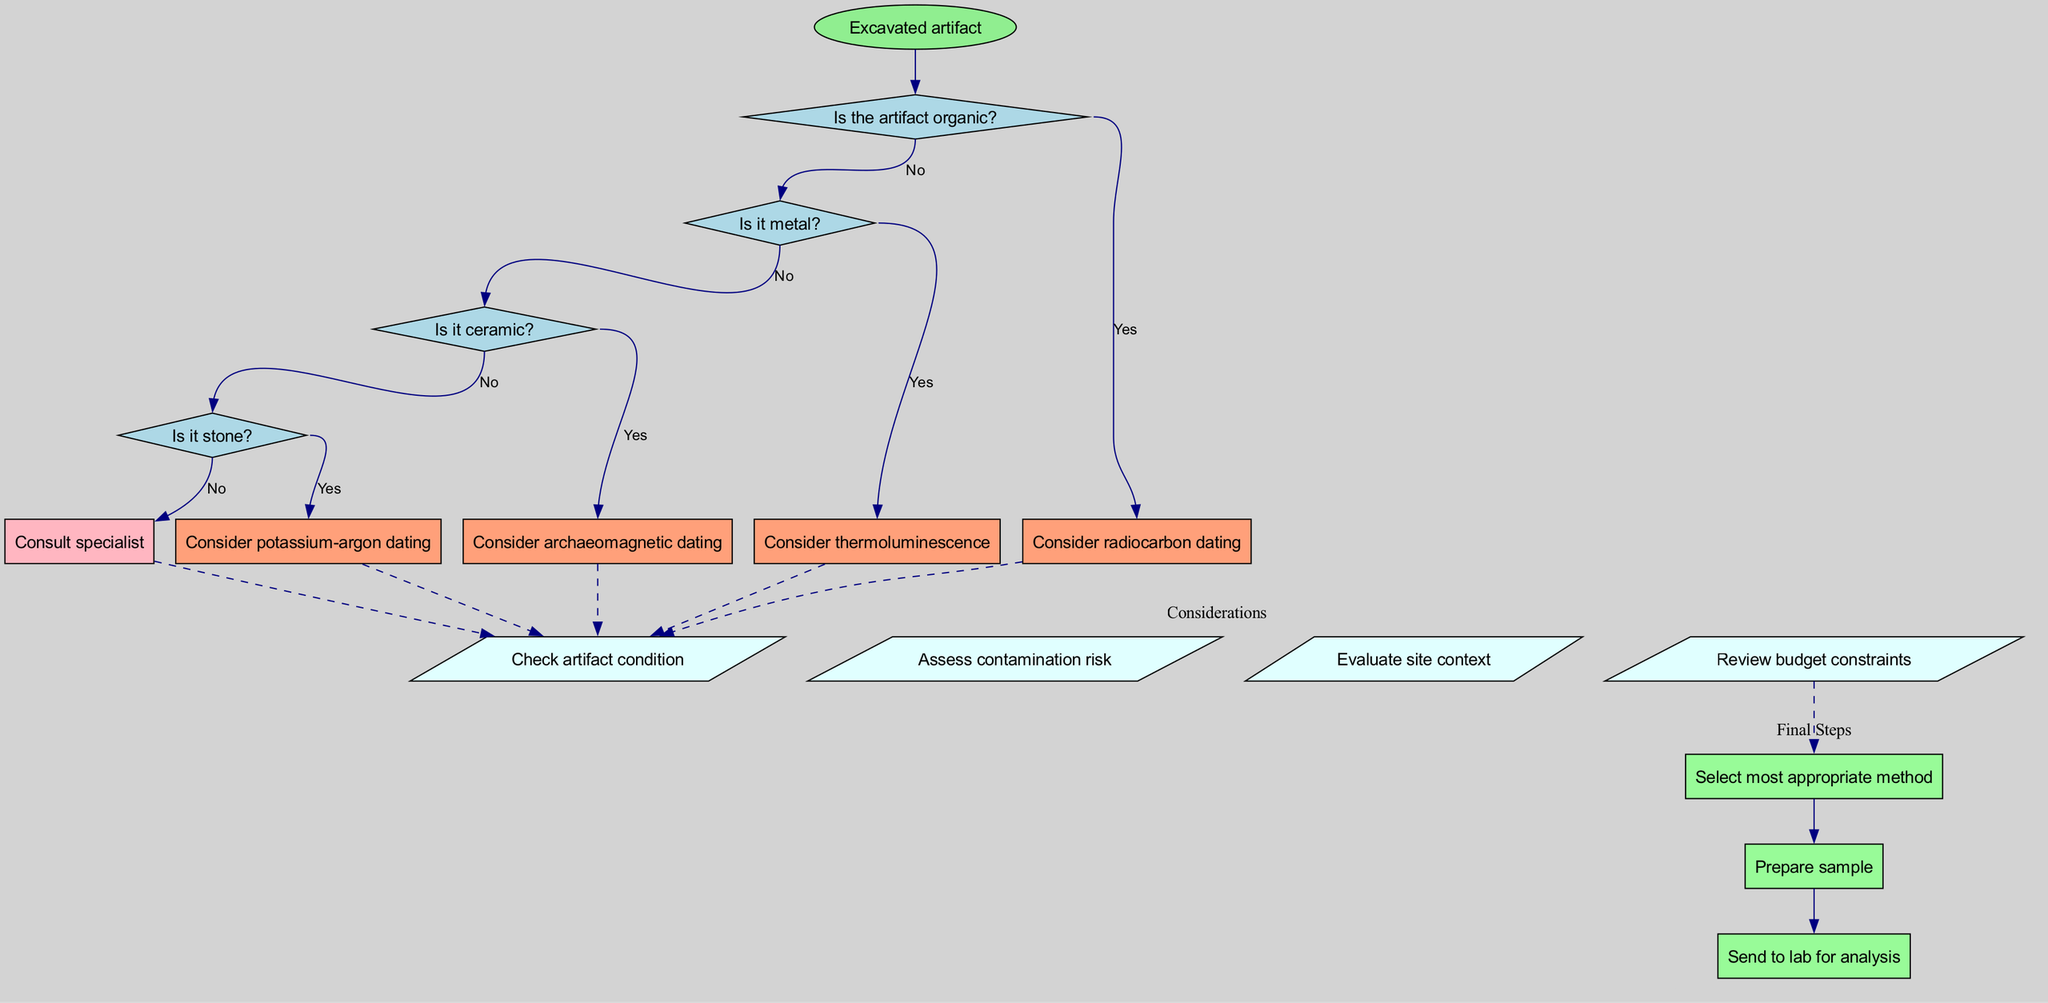What is the starting point of the flow chart? The starting point of the flow chart is represented by the "Excavated artifact" node, which is the initial consideration for the decision-making process regarding artifact dating.
Answer: Excavated artifact How many decisions are represented in the diagram? The diagram contains four decision nodes related to determining the appropriate dating method based on the artifact's type and condition, indicating a branching process for decision-making.
Answer: 4 What dating method should be considered for organic artifacts? If an artifact is determined to be organic, the decision leads to considering radiocarbon dating as the appropriate method for dating such materials.
Answer: Radiocarbon dating What should be consulted if the artifact is stone? If the artifact is identified as stone, and the answer to the prior questions is no, the final action is to "Consult specialist" for guidance on applicable dating methods.
Answer: Consult specialist Which method is suggested for ceramic artifacts? When identifying ceramic artifacts, the flow chart indicates that archaeomagnetic dating should be considered as the appropriate dating method for such materials.
Answer: Archaeomagnetic dating What is the connection between considerations and final steps? The considerations serve as important factors to evaluate before proceeding to the final steps, emphasizing the need to assess issues like contamination risk and budget constraints to ensure a proper selection of the dating method.
Answer: Dashed edges connect them Which decision leads to thermoluminescence dating? The decision regarding whether the artifact is metal leads to the suggestion of thermoluminescence dating if the answer is yes, indicating a specific path based on the material type.
Answer: Is it metal? What is one factor that should be checked before finalizing the dating method? One factor that should be checked before finalizing is the "Check artifact condition" to ensure that the artifact is suitable for the selected dating method in terms of its physical state.
Answer: Check artifact condition What are the final steps mentioned in the flow chart? The flow chart lists three final steps: selecting the most appropriate method, preparing the sample, and sending it to the lab for analysis, which are critical actions to complete the dating process.
Answer: Select most appropriate method, Prepare sample, Send to lab for analysis 